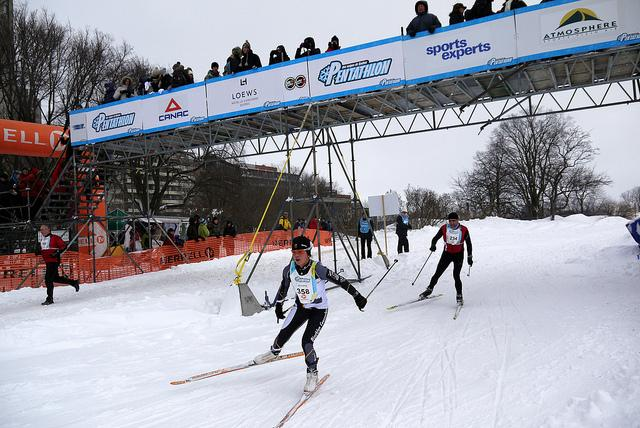What type of signs are shown?

Choices:
A) regulatory
B) directional
C) warning
D) brand brand 